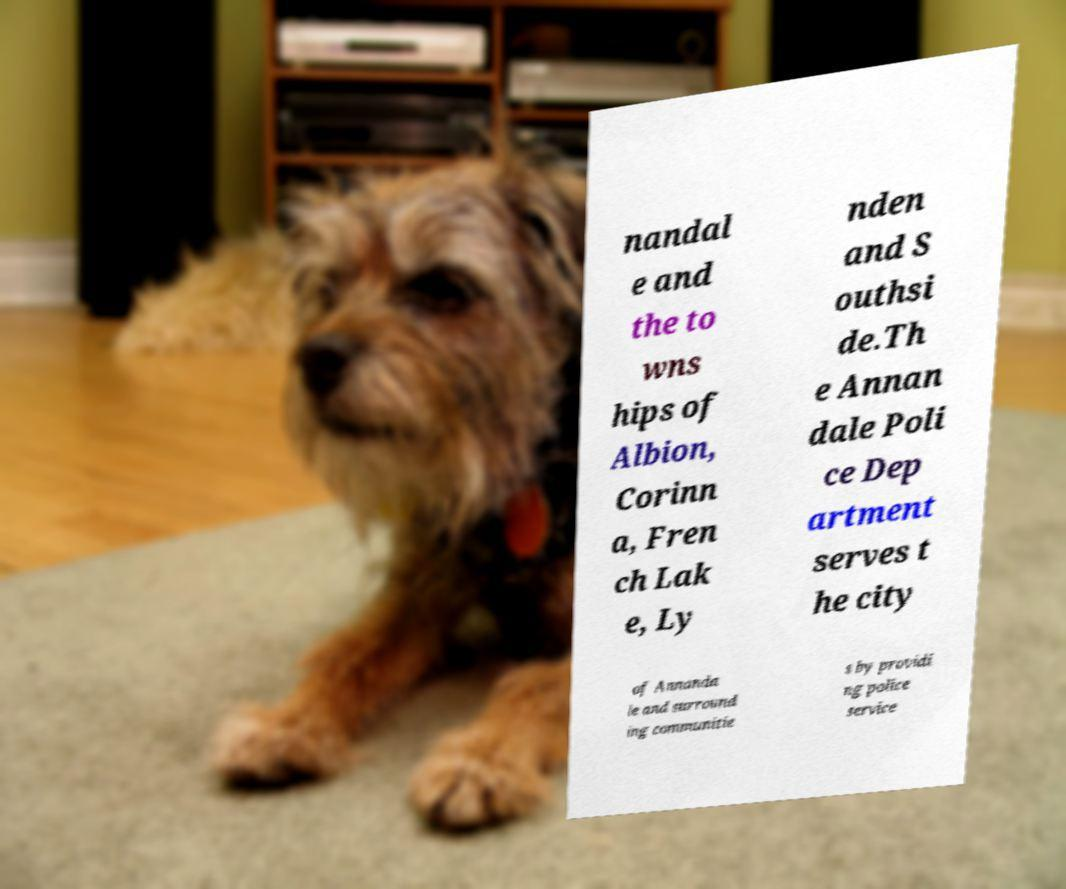Could you extract and type out the text from this image? nandal e and the to wns hips of Albion, Corinn a, Fren ch Lak e, Ly nden and S outhsi de.Th e Annan dale Poli ce Dep artment serves t he city of Annanda le and surround ing communitie s by providi ng police service 